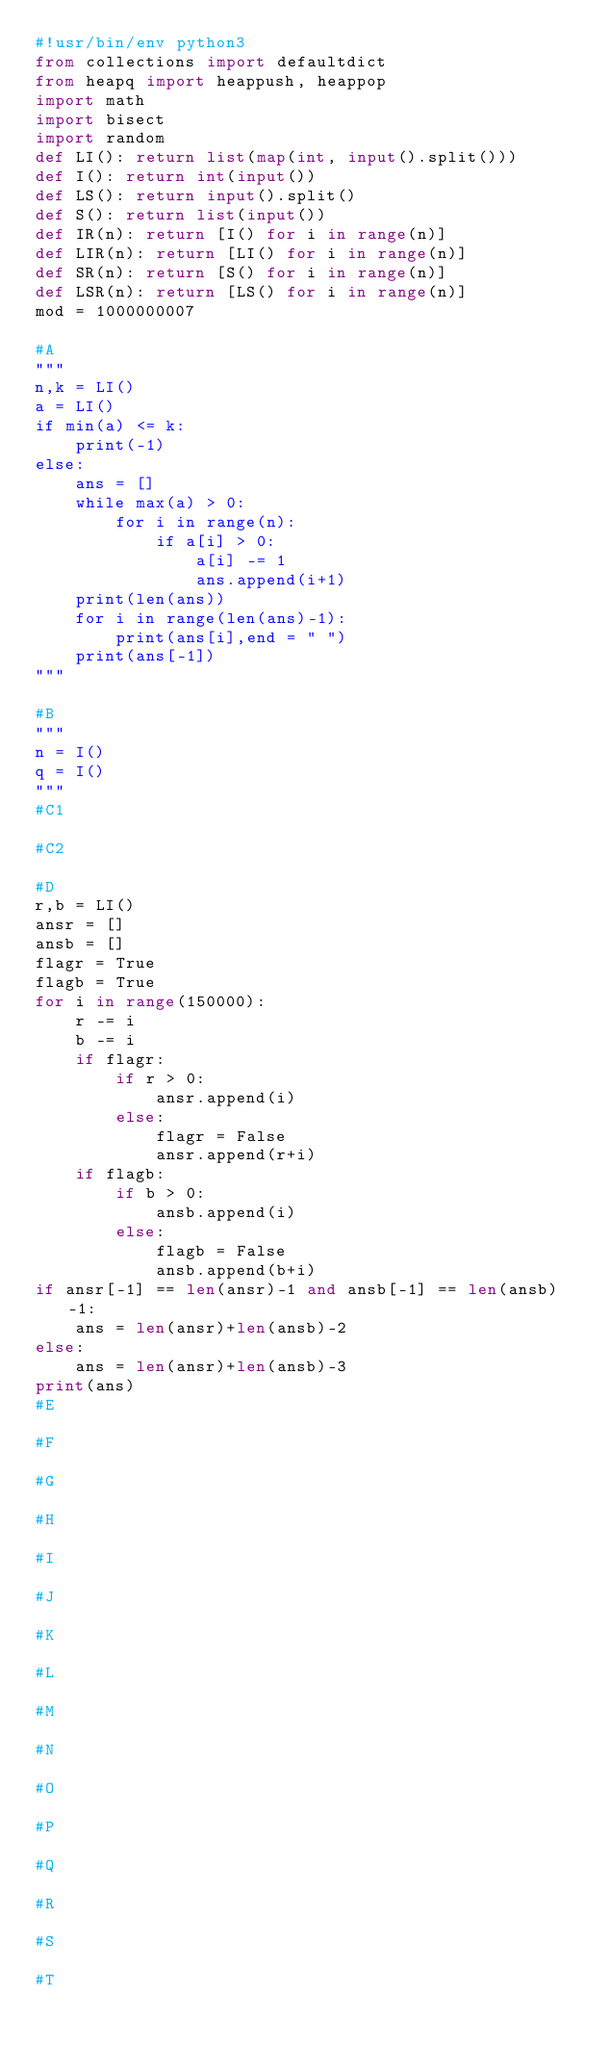Convert code to text. <code><loc_0><loc_0><loc_500><loc_500><_Python_>#!usr/bin/env python3
from collections import defaultdict
from heapq import heappush, heappop
import math
import bisect
import random
def LI(): return list(map(int, input().split()))
def I(): return int(input())
def LS(): return input().split()
def S(): return list(input())
def IR(n): return [I() for i in range(n)]
def LIR(n): return [LI() for i in range(n)]
def SR(n): return [S() for i in range(n)]
def LSR(n): return [LS() for i in range(n)]
mod = 1000000007

#A
"""
n,k = LI()
a = LI()
if min(a) <= k:
    print(-1)
else:
    ans = []
    while max(a) > 0:
        for i in range(n):
            if a[i] > 0:
                a[i] -= 1
                ans.append(i+1)
    print(len(ans))
    for i in range(len(ans)-1):
        print(ans[i],end = " ")
    print(ans[-1])
"""

#B
"""
n = I()
q = I()
"""
#C1

#C2

#D
r,b = LI()
ansr = []
ansb = []
flagr = True
flagb = True
for i in range(150000):
    r -= i
    b -= i
    if flagr:
        if r > 0:
            ansr.append(i)
        else:
            flagr = False
            ansr.append(r+i)
    if flagb:
        if b > 0:
            ansb.append(i)
        else:
            flagb = False
            ansb.append(b+i)
if ansr[-1] == len(ansr)-1 and ansb[-1] == len(ansb)-1:
    ans = len(ansr)+len(ansb)-2
else:
    ans = len(ansr)+len(ansb)-3
print(ans)
#E

#F

#G

#H

#I

#J

#K

#L

#M

#N

#O

#P

#Q

#R

#S

#T
</code> 